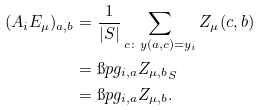Convert formula to latex. <formula><loc_0><loc_0><loc_500><loc_500>( A _ { i } E _ { \mu } ) _ { a , b } & = \frac { 1 } { | S | } \sum _ { c \colon y ( a , c ) = y _ { i } } Z _ { \mu } ( c , b ) \\ & = \i p { g _ { i , a } } { Z _ { \mu , b } } _ { S } \\ & = \i p { g _ { i , a } } { Z _ { \mu , b } } .</formula> 